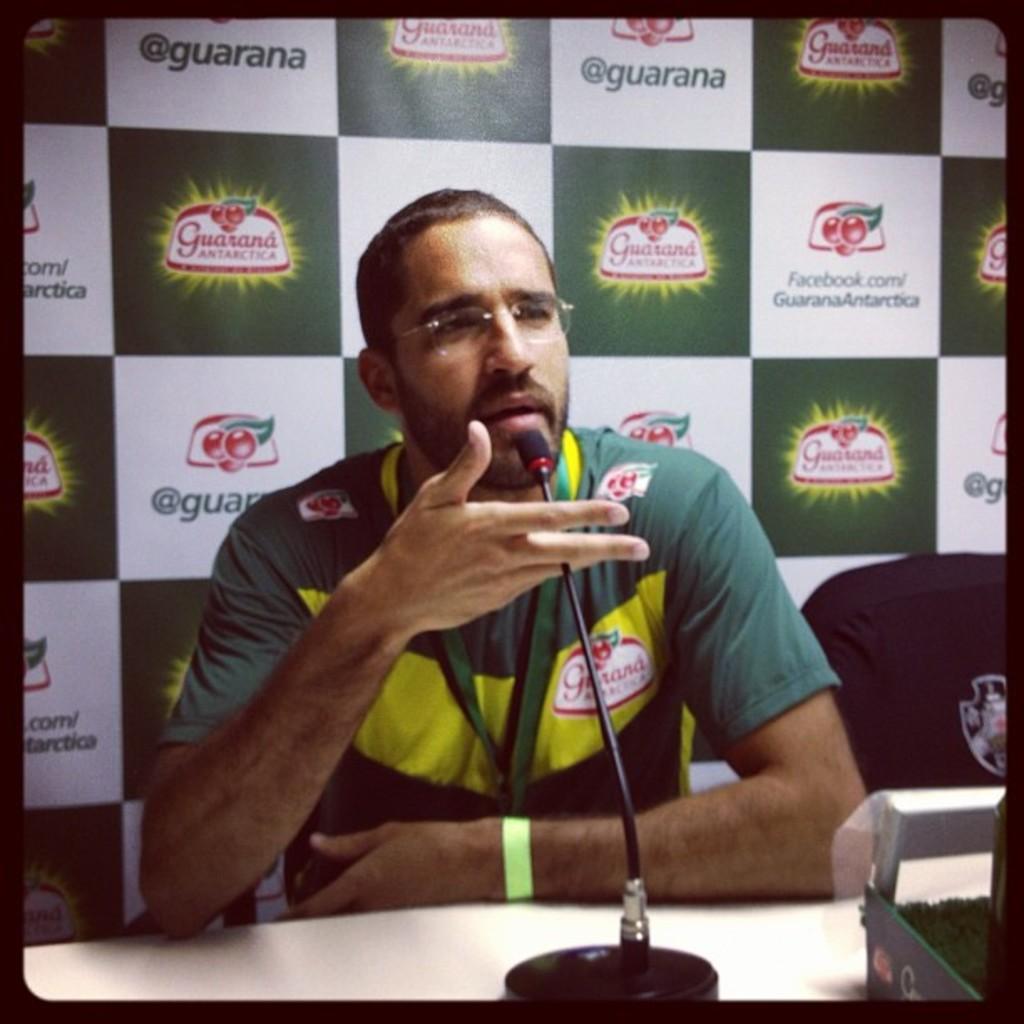Can you describe this image briefly? In this image we can see a man sitting on a chair beside the table containing an object and a mic with a stand on it. We can also see a chair beside him. On the backside we can see a poster with some text on it. 